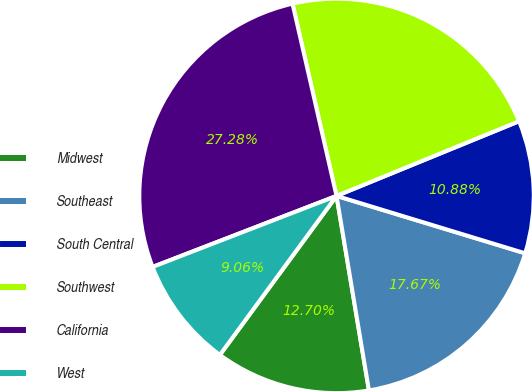Convert chart. <chart><loc_0><loc_0><loc_500><loc_500><pie_chart><fcel>Midwest<fcel>Southeast<fcel>South Central<fcel>Southwest<fcel>California<fcel>West<nl><fcel>12.7%<fcel>17.67%<fcel>10.88%<fcel>22.4%<fcel>27.28%<fcel>9.06%<nl></chart> 